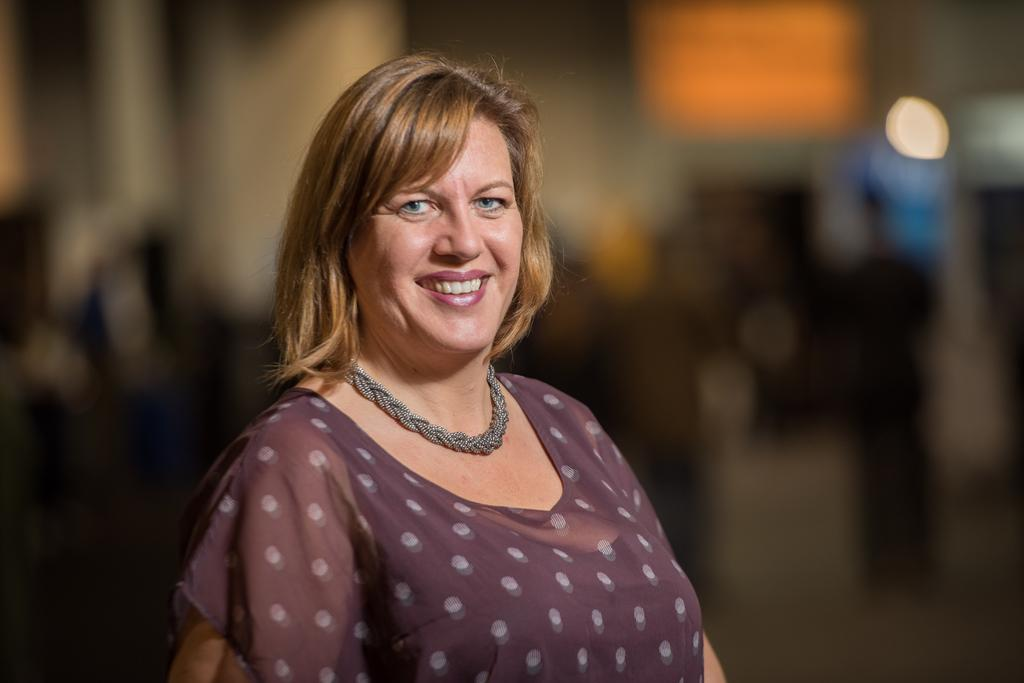What is the main subject of the image? There is a person standing in the image. What is the person's facial expression? The person is smiling. Can you describe the background of the image? The background of the image is blurred. What type of jelly can be seen dripping from the wheel in the image? There is no jelly or wheel present in the image. 